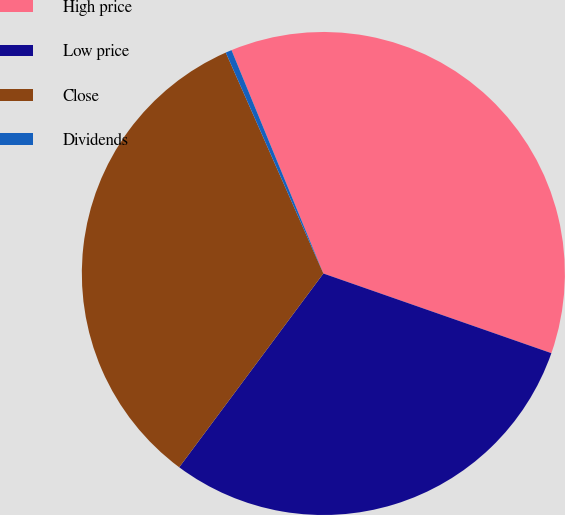<chart> <loc_0><loc_0><loc_500><loc_500><pie_chart><fcel>High price<fcel>Low price<fcel>Close<fcel>Dividends<nl><fcel>36.56%<fcel>29.83%<fcel>33.2%<fcel>0.41%<nl></chart> 